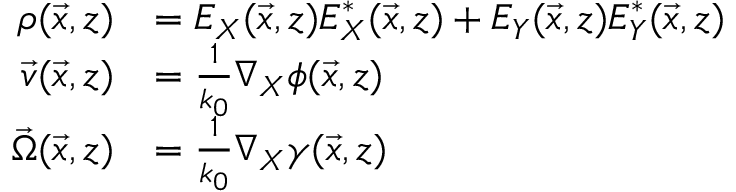Convert formula to latex. <formula><loc_0><loc_0><loc_500><loc_500>\begin{array} { r l } { \rho ( \vec { x } , z ) } & { = E _ { X } ( \vec { x } , z ) E _ { X } ^ { * } ( \vec { x } , z ) + E _ { Y } ( \vec { x } , z ) E _ { Y } ^ { * } ( \vec { x } , z ) } \\ { \vec { v } ( \vec { x } , z ) } & { = \frac { 1 } { k _ { 0 } } \nabla _ { X } \phi ( \vec { x } , z ) } \\ { \vec { \Omega } ( \vec { x } , z ) } & { = \frac { 1 } { k _ { 0 } } \nabla _ { X } \gamma ( \vec { x } , z ) } \end{array}</formula> 